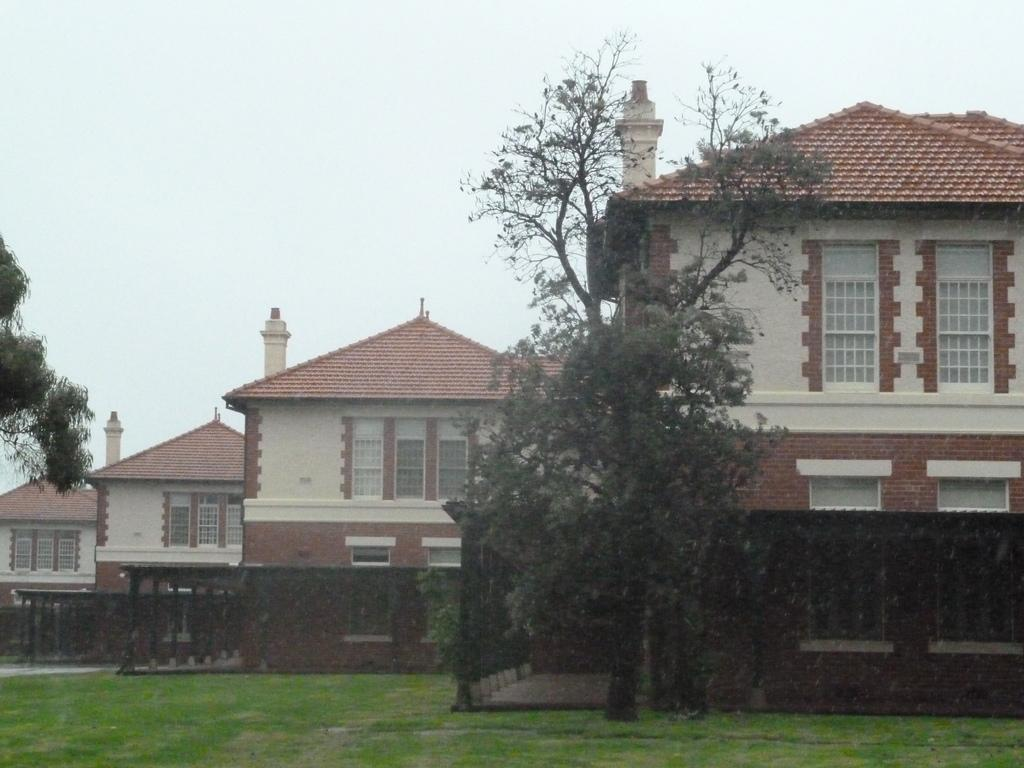What type of vegetation can be seen in the image? There are trees in the image. What type of ground cover is present in the image? There is grass in the image. What type of structures are visible in the image? There are buildings with windows in the image. What is visible in the background of the image? The sky is visible in the background of the image. What mark does the dad leave on the grass in the image? There is no dad present in the image, and therefore no mark can be attributed to him. What relation does the grass have to the trees in the image? The grass and trees are separate elements in the image and do not have a direct relation to each other. 